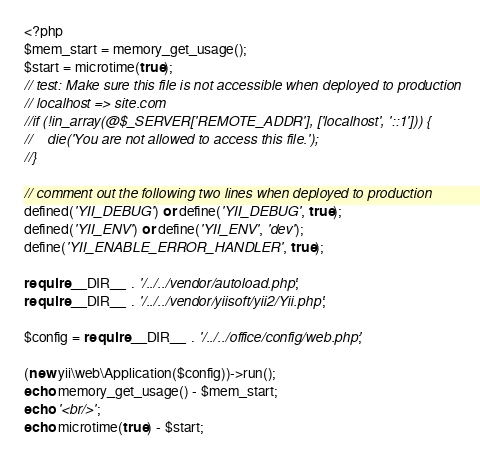Convert code to text. <code><loc_0><loc_0><loc_500><loc_500><_PHP_><?php
$mem_start = memory_get_usage();
$start = microtime(true);
// test: Make sure this file is not accessible when deployed to production
// localhost => site.com
//if (!in_array(@$_SERVER['REMOTE_ADDR'], ['localhost', '::1'])) {
//    die('You are not allowed to access this file.');
//}

// comment out the following two lines when deployed to production
defined('YII_DEBUG') or define('YII_DEBUG', true);
defined('YII_ENV') or define('YII_ENV', 'dev');
define('YII_ENABLE_ERROR_HANDLER', true);

require __DIR__ . '/../../vendor/autoload.php';
require __DIR__ . '/../../vendor/yiisoft/yii2/Yii.php';

$config = require __DIR__ . '/../../office/config/web.php';

(new yii\web\Application($config))->run();
echo memory_get_usage() - $mem_start;
echo '<br/>';
echo microtime(true) - $start;
</code> 